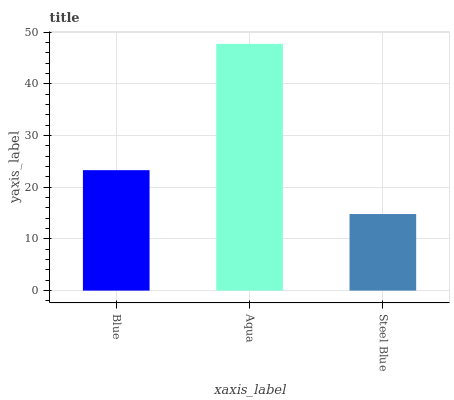Is Steel Blue the minimum?
Answer yes or no. Yes. Is Aqua the maximum?
Answer yes or no. Yes. Is Aqua the minimum?
Answer yes or no. No. Is Steel Blue the maximum?
Answer yes or no. No. Is Aqua greater than Steel Blue?
Answer yes or no. Yes. Is Steel Blue less than Aqua?
Answer yes or no. Yes. Is Steel Blue greater than Aqua?
Answer yes or no. No. Is Aqua less than Steel Blue?
Answer yes or no. No. Is Blue the high median?
Answer yes or no. Yes. Is Blue the low median?
Answer yes or no. Yes. Is Steel Blue the high median?
Answer yes or no. No. Is Aqua the low median?
Answer yes or no. No. 